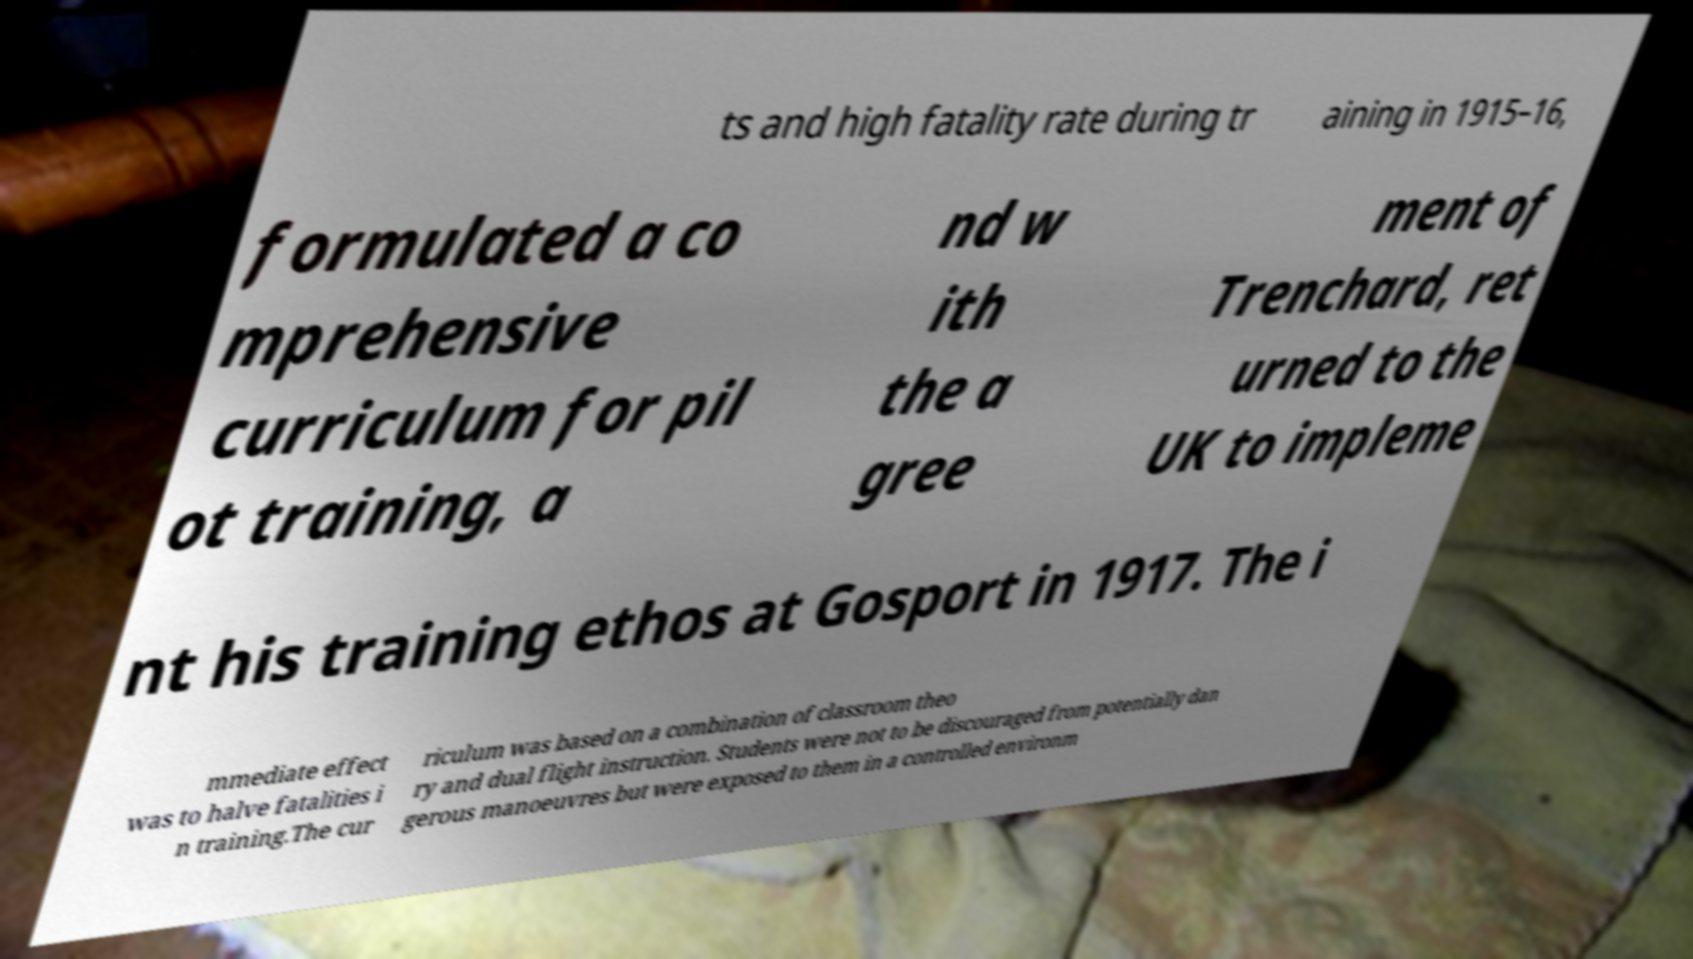What messages or text are displayed in this image? I need them in a readable, typed format. ts and high fatality rate during tr aining in 1915–16, formulated a co mprehensive curriculum for pil ot training, a nd w ith the a gree ment of Trenchard, ret urned to the UK to impleme nt his training ethos at Gosport in 1917. The i mmediate effect was to halve fatalities i n training.The cur riculum was based on a combination of classroom theo ry and dual flight instruction. Students were not to be discouraged from potentially dan gerous manoeuvres but were exposed to them in a controlled environm 